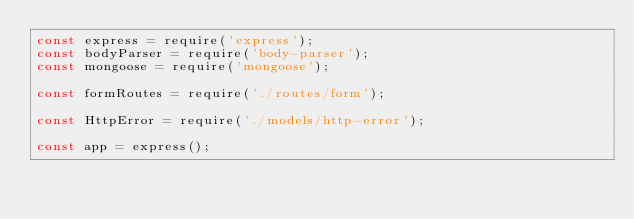Convert code to text. <code><loc_0><loc_0><loc_500><loc_500><_JavaScript_>const express = require('express');
const bodyParser = require('body-parser');
const mongoose = require('mongoose');

const formRoutes = require('./routes/form');

const HttpError = require('./models/http-error');

const app = express();
</code> 